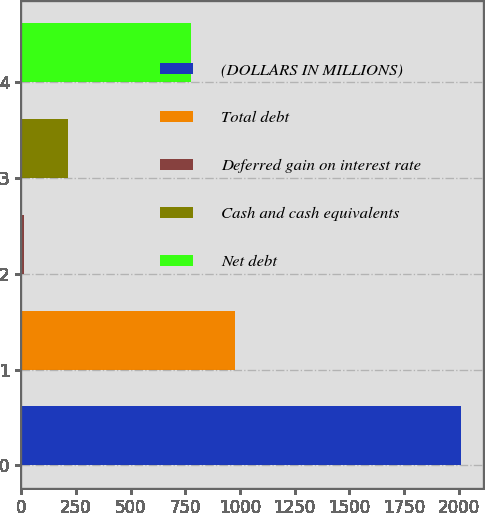Convert chart. <chart><loc_0><loc_0><loc_500><loc_500><bar_chart><fcel>(DOLLARS IN MILLIONS)<fcel>Total debt<fcel>Deferred gain on interest rate<fcel>Cash and cash equivalents<fcel>Net debt<nl><fcel>2010<fcel>977.11<fcel>12.9<fcel>212.61<fcel>777.4<nl></chart> 